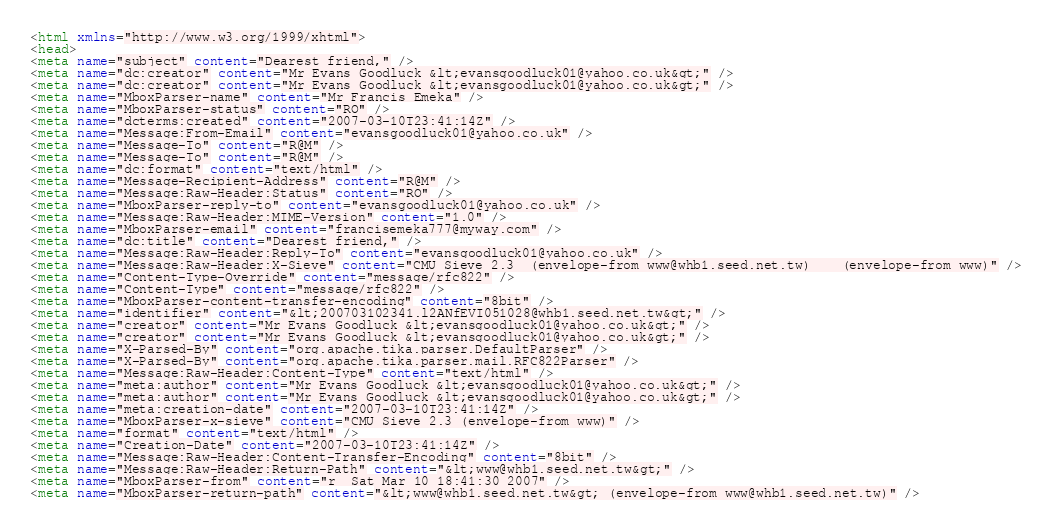Convert code to text. <code><loc_0><loc_0><loc_500><loc_500><_HTML_><html xmlns="http://www.w3.org/1999/xhtml">
<head>
<meta name="subject" content="Dearest friend," />
<meta name="dc:creator" content="Mr Evans Goodluck &lt;evansgoodluck01@yahoo.co.uk&gt;" />
<meta name="dc:creator" content="Mr Evans Goodluck &lt;evansgoodluck01@yahoo.co.uk&gt;" />
<meta name="MboxParser-name" content="Mr Francis Emeka" />
<meta name="MboxParser-status" content="RO" />
<meta name="dcterms:created" content="2007-03-10T23:41:14Z" />
<meta name="Message:From-Email" content="evansgoodluck01@yahoo.co.uk" />
<meta name="Message-To" content="R@M" />
<meta name="Message-To" content="R@M" />
<meta name="dc:format" content="text/html" />
<meta name="Message-Recipient-Address" content="R@M" />
<meta name="Message:Raw-Header:Status" content="RO" />
<meta name="MboxParser-reply-to" content="evansgoodluck01@yahoo.co.uk" />
<meta name="Message:Raw-Header:MIME-Version" content="1.0" />
<meta name="MboxParser-email" content="francisemeka777@myway.com" />
<meta name="dc:title" content="Dearest friend," />
<meta name="Message:Raw-Header:Reply-To" content="evansgoodluck01@yahoo.co.uk" />
<meta name="Message:Raw-Header:X-Sieve" content="CMU Sieve 2.3	(envelope-from www@whb1.seed.net.tw)	(envelope-from www)" />
<meta name="Content-Type-Override" content="message/rfc822" />
<meta name="Content-Type" content="message/rfc822" />
<meta name="MboxParser-content-transfer-encoding" content="8bit" />
<meta name="identifier" content="&lt;200703102341.l2ANfEVI051028@whb1.seed.net.tw&gt;" />
<meta name="creator" content="Mr Evans Goodluck &lt;evansgoodluck01@yahoo.co.uk&gt;" />
<meta name="creator" content="Mr Evans Goodluck &lt;evansgoodluck01@yahoo.co.uk&gt;" />
<meta name="X-Parsed-By" content="org.apache.tika.parser.DefaultParser" />
<meta name="X-Parsed-By" content="org.apache.tika.parser.mail.RFC822Parser" />
<meta name="Message:Raw-Header:Content-Type" content="text/html" />
<meta name="meta:author" content="Mr Evans Goodluck &lt;evansgoodluck01@yahoo.co.uk&gt;" />
<meta name="meta:author" content="Mr Evans Goodluck &lt;evansgoodluck01@yahoo.co.uk&gt;" />
<meta name="meta:creation-date" content="2007-03-10T23:41:14Z" />
<meta name="MboxParser-x-sieve" content="CMU Sieve 2.3 (envelope-from www)" />
<meta name="format" content="text/html" />
<meta name="Creation-Date" content="2007-03-10T23:41:14Z" />
<meta name="Message:Raw-Header:Content-Transfer-Encoding" content="8bit" />
<meta name="Message:Raw-Header:Return-Path" content="&lt;www@whb1.seed.net.tw&gt;" />
<meta name="MboxParser-from" content="r  Sat Mar 10 18:41:30 2007" />
<meta name="MboxParser-return-path" content="&lt;www@whb1.seed.net.tw&gt; (envelope-from www@whb1.seed.net.tw)" /></code> 